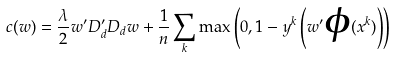<formula> <loc_0><loc_0><loc_500><loc_500>c ( w ) = \frac { \lambda } { 2 } w ^ { \prime } D _ { d } ^ { \prime } D _ { d } w + \frac { 1 } { n } \sum _ { k } \max \left ( 0 , 1 - y ^ { k } \left ( w ^ { \prime } \boldsymbol \phi ( x ^ { k } ) \right ) \right )</formula> 